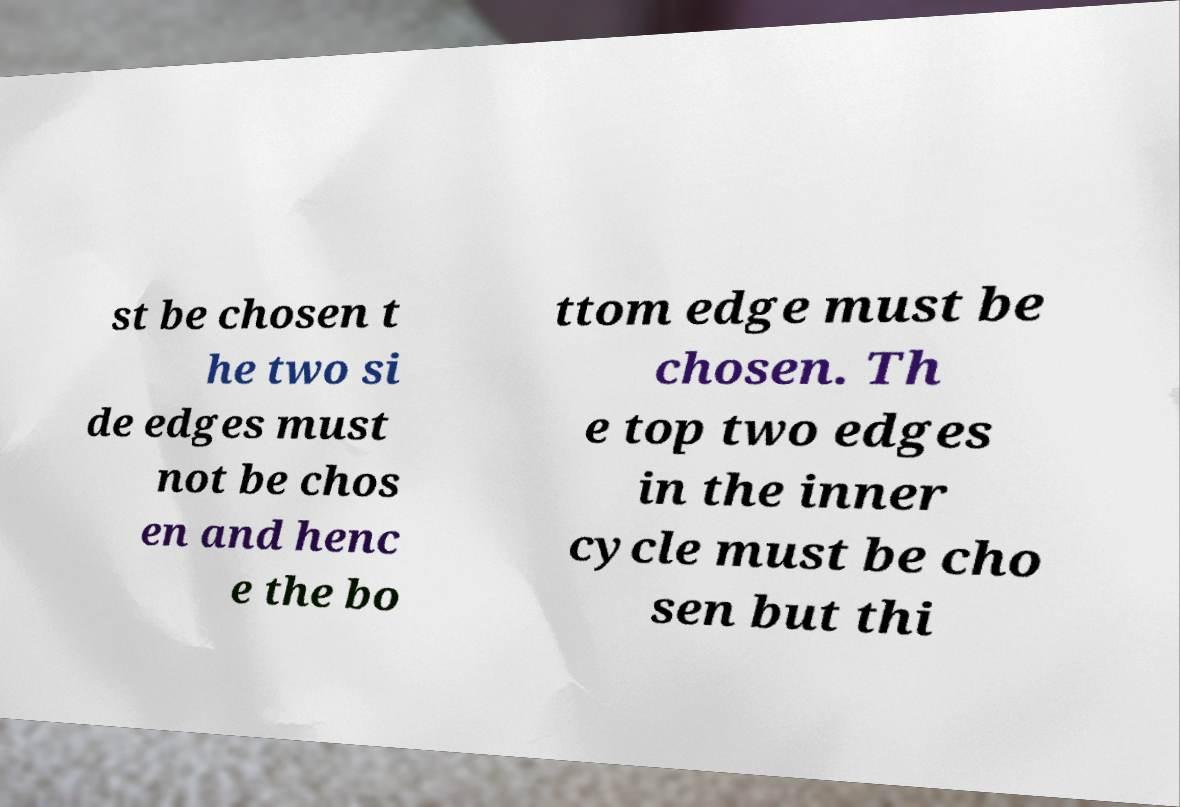Can you accurately transcribe the text from the provided image for me? st be chosen t he two si de edges must not be chos en and henc e the bo ttom edge must be chosen. Th e top two edges in the inner cycle must be cho sen but thi 